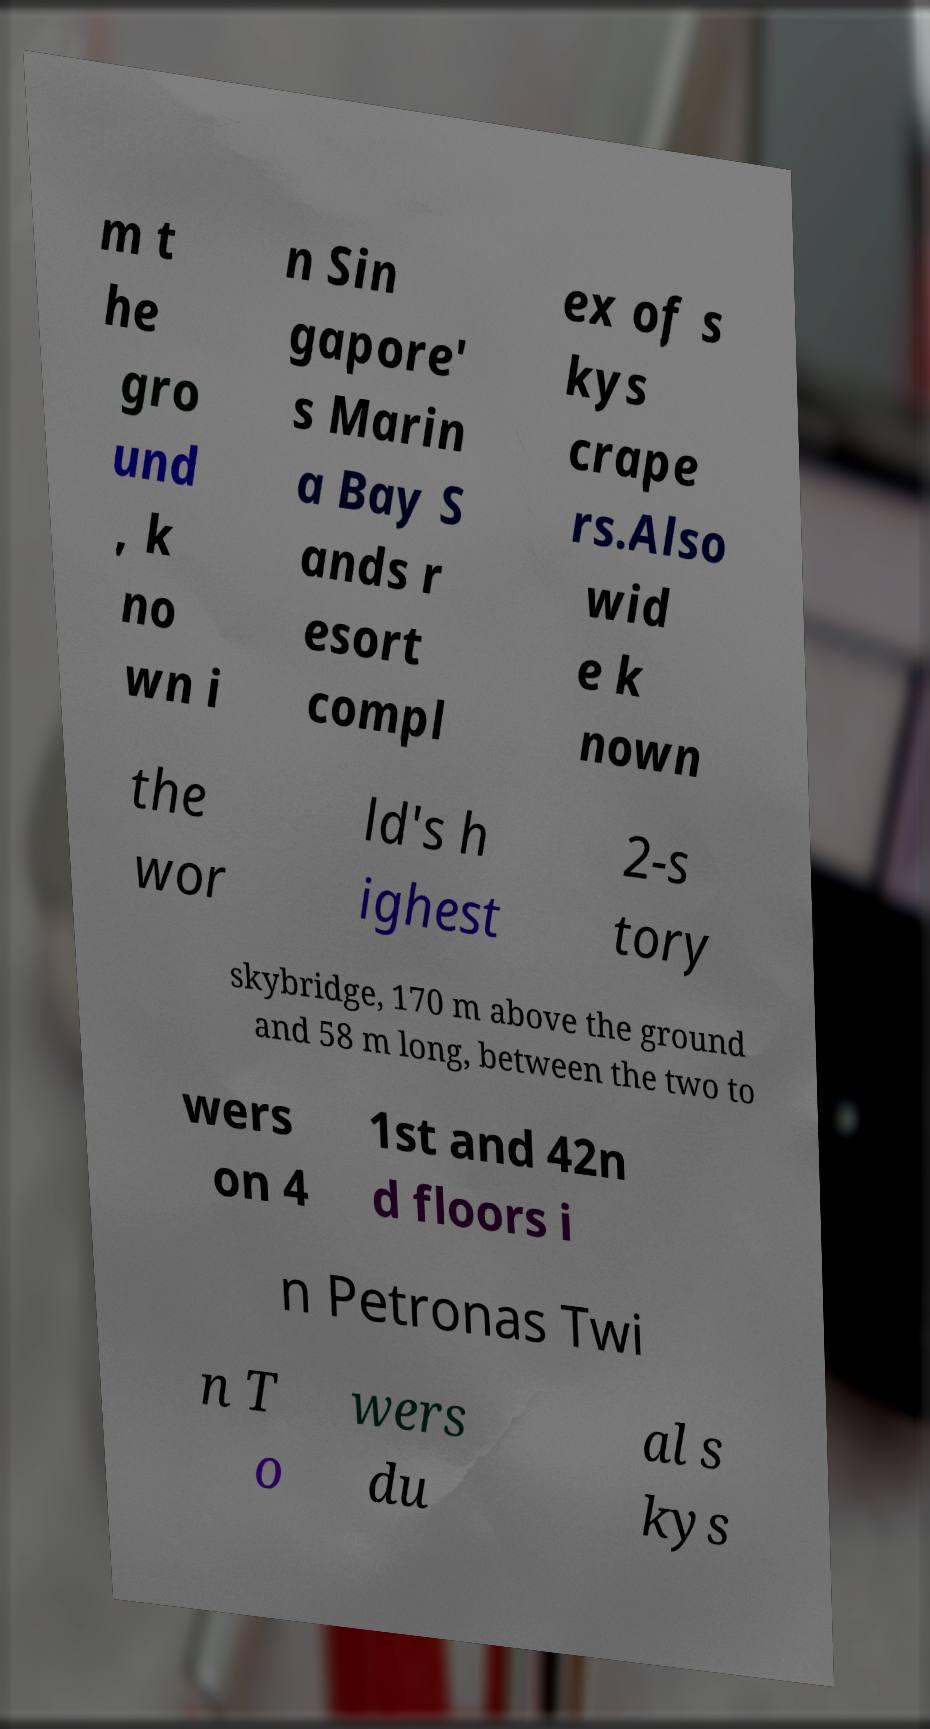What messages or text are displayed in this image? I need them in a readable, typed format. m t he gro und , k no wn i n Sin gapore' s Marin a Bay S ands r esort compl ex of s kys crape rs.Also wid e k nown the wor ld's h ighest 2-s tory skybridge, 170 m above the ground and 58 m long, between the two to wers on 4 1st and 42n d floors i n Petronas Twi n T o wers du al s kys 